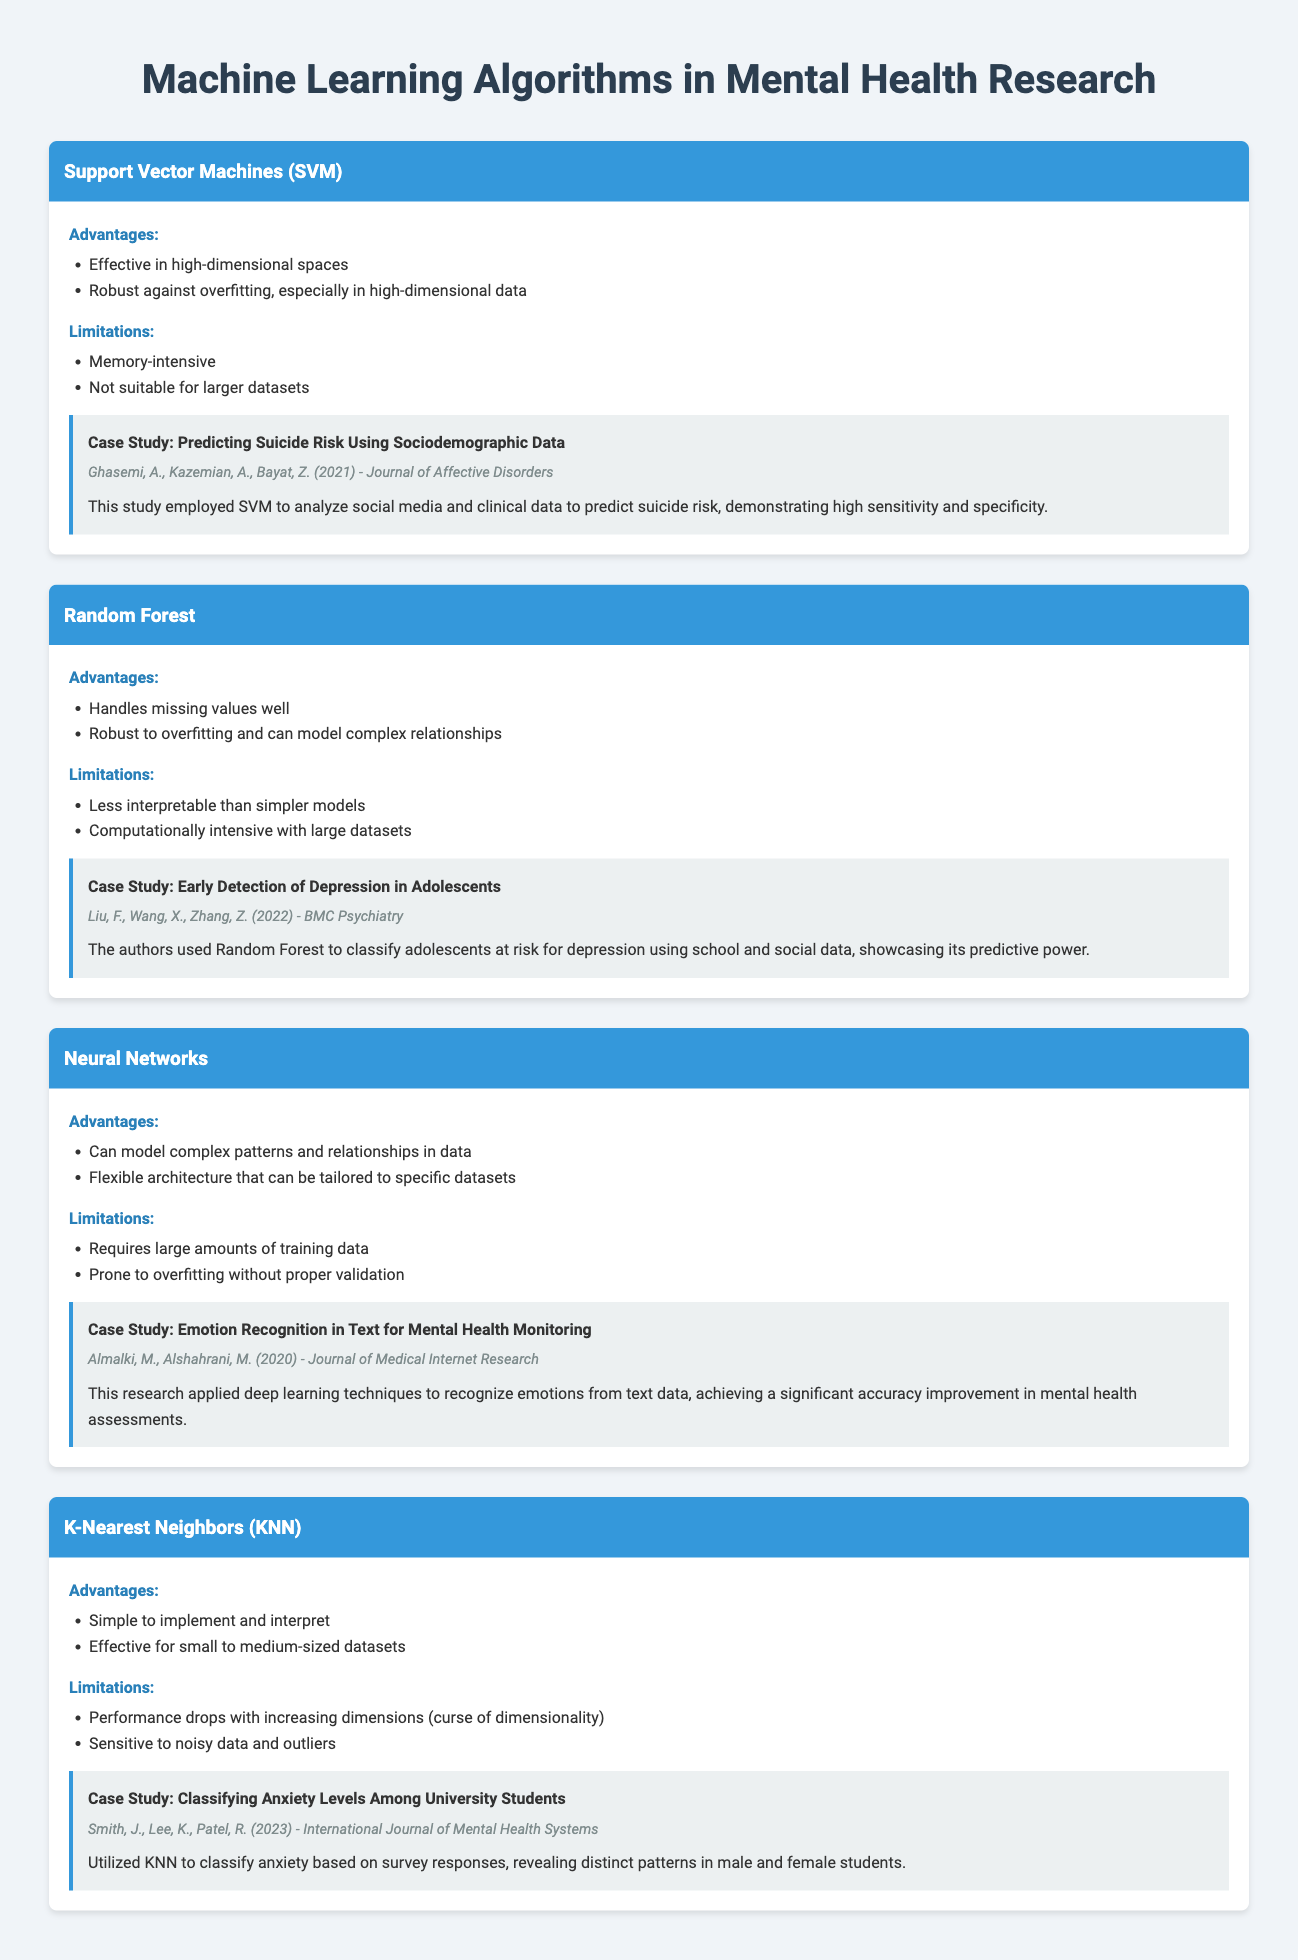What is the first algorithm listed in the document? The first algorithm mentioned in the document is Support Vector Machines (SVM).
Answer: Support Vector Machines (SVM) How many case studies are mentioned in total? There are four case studies listed in the document, one for each algorithm discussed.
Answer: 4 What is a limitation of Neural Networks? A key limitation of Neural Networks is that they require large amounts of training data.
Answer: Requires large amounts of training data Which algorithm is highlighted for handling missing values well? The algorithm that handles missing values well is Random Forest.
Answer: Random Forest Who conducted the case study on predicting suicide risk? The case study on predicting suicide risk was conducted by Ghasemi, A., Kazemian, A., and Bayat, Z.
Answer: Ghasemi, A., Kazemian, A., Bayat, Z What is the main advantage of K-Nearest Neighbors (KNN)? A main advantage of K-Nearest Neighbors (KNN) is that it is simple to implement and interpret.
Answer: Simple to implement and interpret In which year was the case study on early detection of depression published? The case study on early detection of depression was published in 2022.
Answer: 2022 What is a disadvantage of using Random Forest? A disadvantage of using Random Forest is that it is less interpretable than simpler models.
Answer: Less interpretable than simpler models Which journal published the emotion recognition study? The emotion recognition study was published in the Journal of Medical Internet Research.
Answer: Journal of Medical Internet Research 